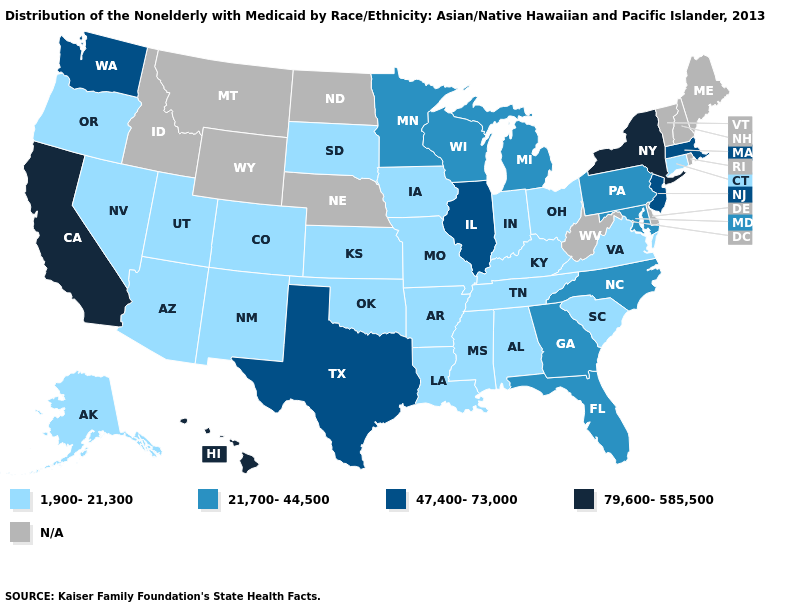Name the states that have a value in the range 47,400-73,000?
Be succinct. Illinois, Massachusetts, New Jersey, Texas, Washington. Name the states that have a value in the range 79,600-585,500?
Be succinct. California, Hawaii, New York. Among the states that border Vermont , does Massachusetts have the highest value?
Concise answer only. No. What is the highest value in the USA?
Answer briefly. 79,600-585,500. How many symbols are there in the legend?
Concise answer only. 5. Name the states that have a value in the range 79,600-585,500?
Keep it brief. California, Hawaii, New York. What is the value of Idaho?
Concise answer only. N/A. Does the first symbol in the legend represent the smallest category?
Be succinct. Yes. What is the value of Oklahoma?
Give a very brief answer. 1,900-21,300. Name the states that have a value in the range 47,400-73,000?
Give a very brief answer. Illinois, Massachusetts, New Jersey, Texas, Washington. Does Colorado have the lowest value in the West?
Keep it brief. Yes. Name the states that have a value in the range 79,600-585,500?
Give a very brief answer. California, Hawaii, New York. What is the value of Colorado?
Give a very brief answer. 1,900-21,300. Name the states that have a value in the range N/A?
Write a very short answer. Delaware, Idaho, Maine, Montana, Nebraska, New Hampshire, North Dakota, Rhode Island, Vermont, West Virginia, Wyoming. 